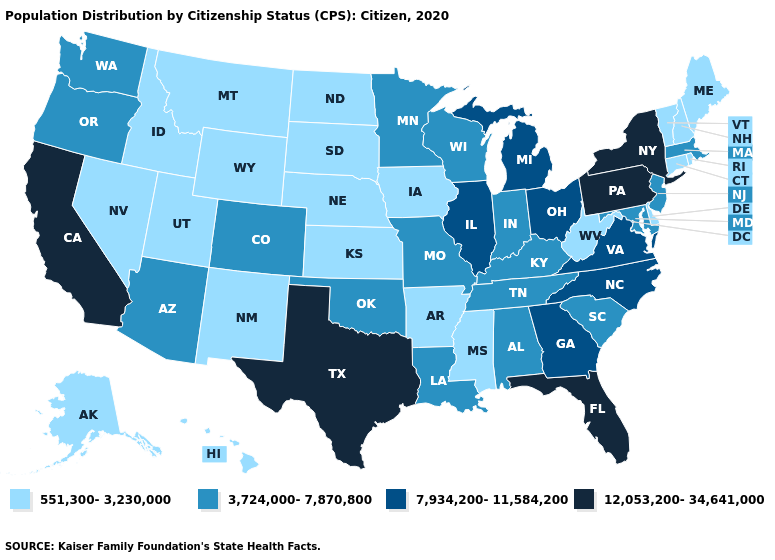Name the states that have a value in the range 551,300-3,230,000?
Write a very short answer. Alaska, Arkansas, Connecticut, Delaware, Hawaii, Idaho, Iowa, Kansas, Maine, Mississippi, Montana, Nebraska, Nevada, New Hampshire, New Mexico, North Dakota, Rhode Island, South Dakota, Utah, Vermont, West Virginia, Wyoming. Name the states that have a value in the range 3,724,000-7,870,800?
Concise answer only. Alabama, Arizona, Colorado, Indiana, Kentucky, Louisiana, Maryland, Massachusetts, Minnesota, Missouri, New Jersey, Oklahoma, Oregon, South Carolina, Tennessee, Washington, Wisconsin. Among the states that border Delaware , does New Jersey have the lowest value?
Concise answer only. Yes. Is the legend a continuous bar?
Quick response, please. No. Does Wyoming have the lowest value in the USA?
Give a very brief answer. Yes. Name the states that have a value in the range 7,934,200-11,584,200?
Concise answer only. Georgia, Illinois, Michigan, North Carolina, Ohio, Virginia. Among the states that border Texas , does Arkansas have the highest value?
Be succinct. No. Does Missouri have a lower value than Pennsylvania?
Write a very short answer. Yes. Which states hav the highest value in the West?
Short answer required. California. Does North Dakota have a higher value than New Hampshire?
Concise answer only. No. What is the highest value in the MidWest ?
Concise answer only. 7,934,200-11,584,200. Name the states that have a value in the range 3,724,000-7,870,800?
Concise answer only. Alabama, Arizona, Colorado, Indiana, Kentucky, Louisiana, Maryland, Massachusetts, Minnesota, Missouri, New Jersey, Oklahoma, Oregon, South Carolina, Tennessee, Washington, Wisconsin. What is the value of Delaware?
Answer briefly. 551,300-3,230,000. Name the states that have a value in the range 7,934,200-11,584,200?
Quick response, please. Georgia, Illinois, Michigan, North Carolina, Ohio, Virginia. Name the states that have a value in the range 7,934,200-11,584,200?
Answer briefly. Georgia, Illinois, Michigan, North Carolina, Ohio, Virginia. 